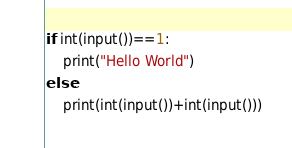Convert code to text. <code><loc_0><loc_0><loc_500><loc_500><_Python_>if int(input())==1:
    print("Hello World")
else:
    print(int(input())+int(input()))</code> 